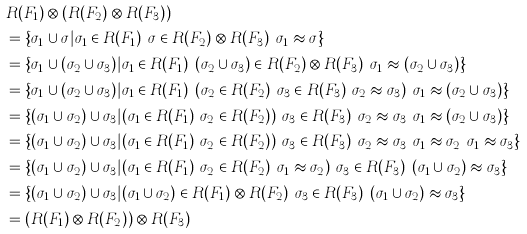Convert formula to latex. <formula><loc_0><loc_0><loc_500><loc_500>& R ( F _ { 1 } ) \otimes ( R ( F _ { 2 } ) \otimes R ( F _ { 3 } ) ) \\ & = \{ \sigma _ { 1 } \cup \sigma | \sigma _ { 1 } \in R ( F _ { 1 } ) \land \sigma \in R ( F _ { 2 } ) \otimes R ( F _ { 3 } ) \land \sigma _ { 1 } \approx \sigma \} \\ & = \{ \sigma _ { 1 } \cup ( \sigma _ { 2 } \cup \sigma _ { 3 } ) | \sigma _ { 1 } \in R ( F _ { 1 } ) \land ( \sigma _ { 2 } \cup \sigma _ { 3 } ) \in R ( F _ { 2 } ) \otimes R ( F _ { 3 } ) \land \sigma _ { 1 } \approx ( \sigma _ { 2 } \cup \sigma _ { 3 } ) \} \\ & = \{ \sigma _ { 1 } \cup ( \sigma _ { 2 } \cup \sigma _ { 3 } ) | \sigma _ { 1 } \in R ( F _ { 1 } ) \land ( \sigma _ { 2 } \in R ( F _ { 2 } ) \land \sigma _ { 3 } \in R ( F _ { 3 } ) \land \sigma _ { 2 } \approx \sigma _ { 3 } ) \land \sigma _ { 1 } \approx ( \sigma _ { 2 } \cup \sigma _ { 3 } ) \} \\ & = \{ ( \sigma _ { 1 } \cup \sigma _ { 2 } ) \cup \sigma _ { 3 } | ( \sigma _ { 1 } \in R ( F _ { 1 } ) \land \sigma _ { 2 } \in R ( F _ { 2 } ) ) \land \sigma _ { 3 } \in R ( F _ { 3 } ) \land \sigma _ { 2 } \approx \sigma _ { 3 } \land \sigma _ { 1 } \approx ( \sigma _ { 2 } \cup \sigma _ { 3 } ) \} \\ & = \{ ( \sigma _ { 1 } \cup \sigma _ { 2 } ) \cup \sigma _ { 3 } | ( \sigma _ { 1 } \in R ( F _ { 1 } ) \land \sigma _ { 2 } \in R ( F _ { 2 } ) ) \land \sigma _ { 3 } \in R ( F _ { 3 } ) \land \sigma _ { 2 } \approx \sigma _ { 3 } \land \sigma _ { 1 } \approx \sigma _ { 2 } \land \sigma _ { 1 } \approx \sigma _ { 3 } \} \\ & = \{ ( \sigma _ { 1 } \cup \sigma _ { 2 } ) \cup \sigma _ { 3 } | ( \sigma _ { 1 } \in R ( F _ { 1 } ) \land \sigma _ { 2 } \in R ( F _ { 2 } ) \land \sigma _ { 1 } \approx \sigma _ { 2 } ) \land \sigma _ { 3 } \in R ( F _ { 3 } ) \land ( \sigma _ { 1 } \cup \sigma _ { 2 } ) \approx \sigma _ { 3 } \} \\ & = \{ ( \sigma _ { 1 } \cup \sigma _ { 2 } ) \cup \sigma _ { 3 } | ( \sigma _ { 1 } \cup \sigma _ { 2 } ) \in R ( F _ { 1 } ) \otimes R ( F _ { 2 } ) \land \sigma _ { 3 } \in R ( F _ { 3 } ) \land ( \sigma _ { 1 } \cup \sigma _ { 2 } ) \approx \sigma _ { 3 } \} \\ & = ( R ( F _ { 1 } ) \otimes R ( F _ { 2 } ) ) \otimes R ( F _ { 3 } )</formula> 